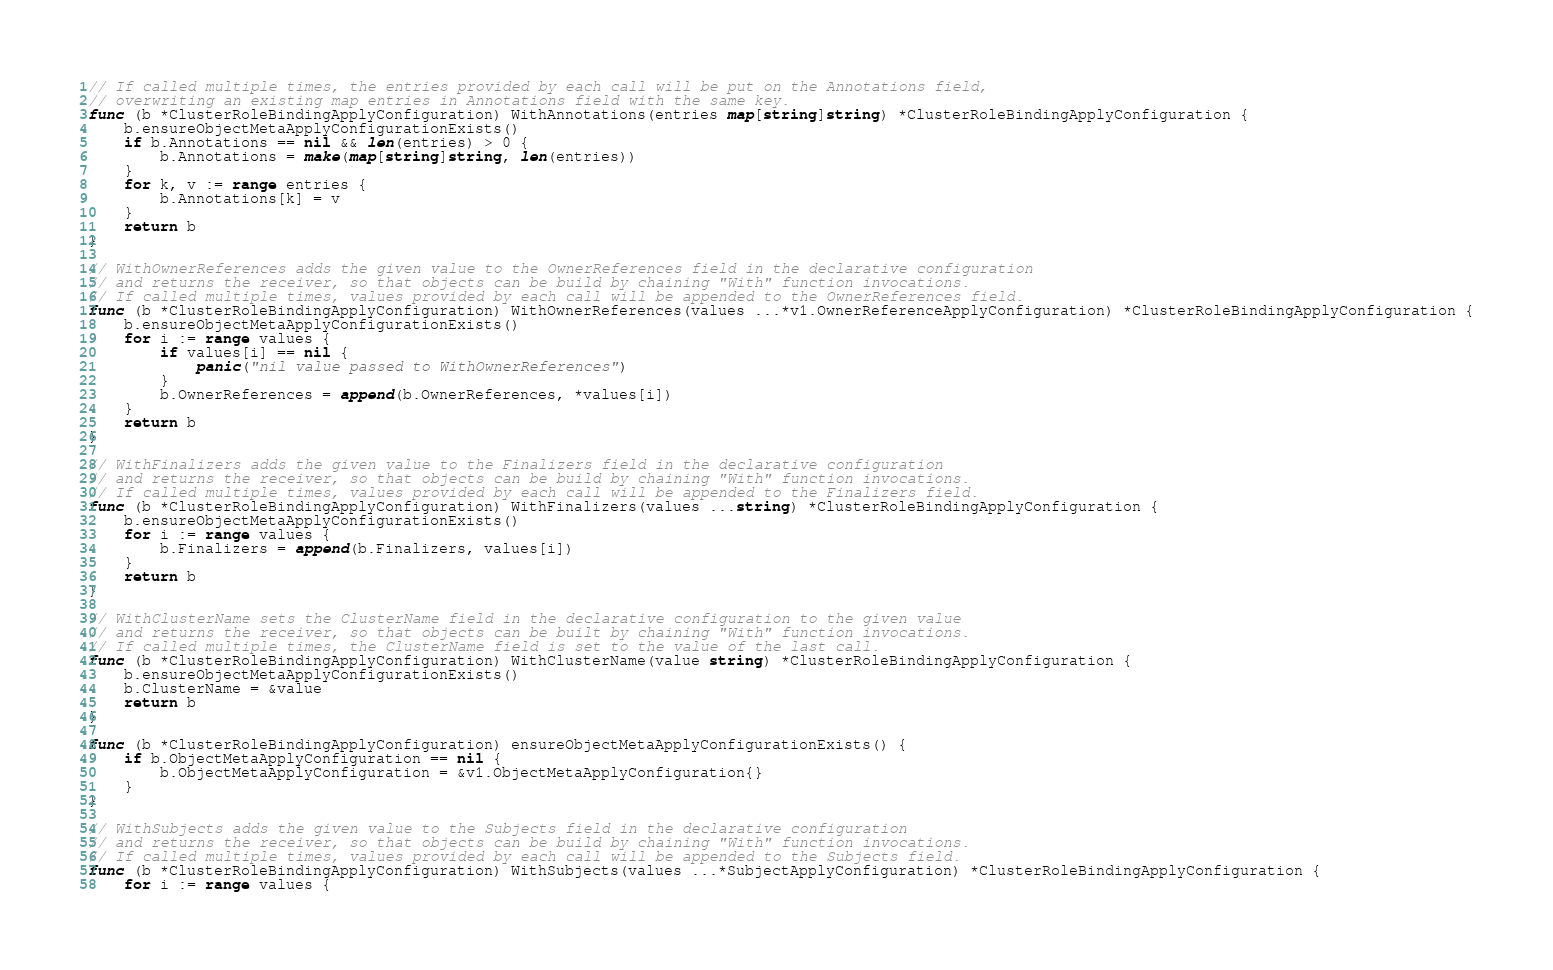Convert code to text. <code><loc_0><loc_0><loc_500><loc_500><_Go_>// If called multiple times, the entries provided by each call will be put on the Annotations field,
// overwriting an existing map entries in Annotations field with the same key.
func (b *ClusterRoleBindingApplyConfiguration) WithAnnotations(entries map[string]string) *ClusterRoleBindingApplyConfiguration {
	b.ensureObjectMetaApplyConfigurationExists()
	if b.Annotations == nil && len(entries) > 0 {
		b.Annotations = make(map[string]string, len(entries))
	}
	for k, v := range entries {
		b.Annotations[k] = v
	}
	return b
}

// WithOwnerReferences adds the given value to the OwnerReferences field in the declarative configuration
// and returns the receiver, so that objects can be build by chaining "With" function invocations.
// If called multiple times, values provided by each call will be appended to the OwnerReferences field.
func (b *ClusterRoleBindingApplyConfiguration) WithOwnerReferences(values ...*v1.OwnerReferenceApplyConfiguration) *ClusterRoleBindingApplyConfiguration {
	b.ensureObjectMetaApplyConfigurationExists()
	for i := range values {
		if values[i] == nil {
			panic("nil value passed to WithOwnerReferences")
		}
		b.OwnerReferences = append(b.OwnerReferences, *values[i])
	}
	return b
}

// WithFinalizers adds the given value to the Finalizers field in the declarative configuration
// and returns the receiver, so that objects can be build by chaining "With" function invocations.
// If called multiple times, values provided by each call will be appended to the Finalizers field.
func (b *ClusterRoleBindingApplyConfiguration) WithFinalizers(values ...string) *ClusterRoleBindingApplyConfiguration {
	b.ensureObjectMetaApplyConfigurationExists()
	for i := range values {
		b.Finalizers = append(b.Finalizers, values[i])
	}
	return b
}

// WithClusterName sets the ClusterName field in the declarative configuration to the given value
// and returns the receiver, so that objects can be built by chaining "With" function invocations.
// If called multiple times, the ClusterName field is set to the value of the last call.
func (b *ClusterRoleBindingApplyConfiguration) WithClusterName(value string) *ClusterRoleBindingApplyConfiguration {
	b.ensureObjectMetaApplyConfigurationExists()
	b.ClusterName = &value
	return b
}

func (b *ClusterRoleBindingApplyConfiguration) ensureObjectMetaApplyConfigurationExists() {
	if b.ObjectMetaApplyConfiguration == nil {
		b.ObjectMetaApplyConfiguration = &v1.ObjectMetaApplyConfiguration{}
	}
}

// WithSubjects adds the given value to the Subjects field in the declarative configuration
// and returns the receiver, so that objects can be build by chaining "With" function invocations.
// If called multiple times, values provided by each call will be appended to the Subjects field.
func (b *ClusterRoleBindingApplyConfiguration) WithSubjects(values ...*SubjectApplyConfiguration) *ClusterRoleBindingApplyConfiguration {
	for i := range values {</code> 